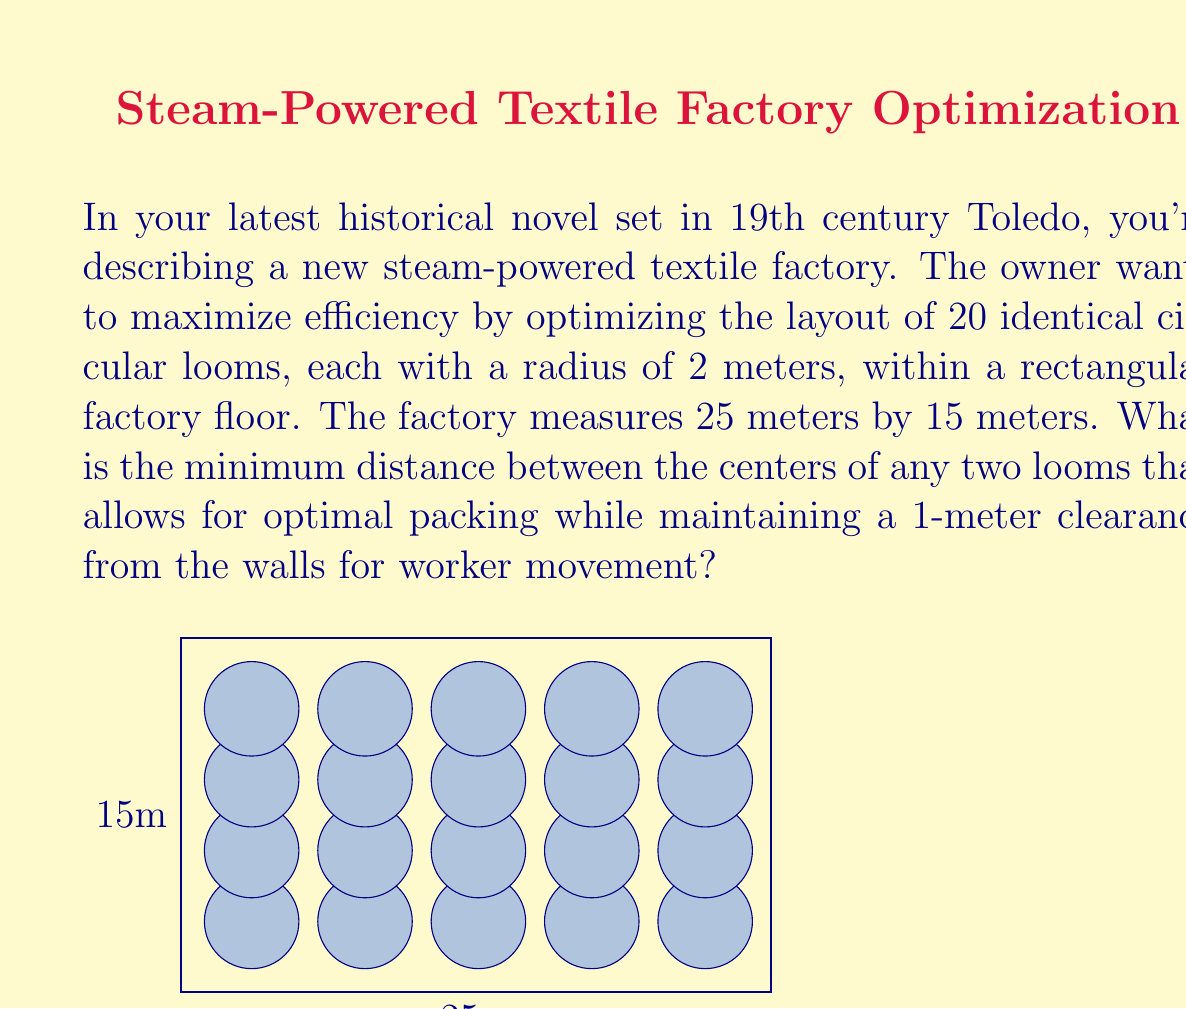Teach me how to tackle this problem. To solve this problem, we'll use computational geometry techniques:

1. First, we need to account for the 1-meter clearance from the walls. This reduces our effective area to 23m x 13m.

2. For optimal packing of circles, we use a hexagonal close packing arrangement. In this arrangement, the distance between circle centers is equal to their diameter.

3. Let $d$ be the distance between loom centers. Given the loom radius of 2m, we have:
   $d = 2r + x$, where $r = 2$ and $x$ is the extra space between looms.

4. In the longer dimension (23m), we can fit:
   $n_1 = \lfloor \frac{23}{d} \rfloor + 1$ looms

5. In the shorter dimension (13m), we can fit:
   $n_2 = \lfloor \frac{13}{\frac{\sqrt{3}}{2}d} \rfloor + 1$ looms

6. We need to maximize $n_1 \times n_2$ while ensuring it's at least 20 (the number of looms).

7. Through iterative calculation, we find that the optimal arrangement is 5 x 4 looms.

8. For 5 looms in 23m: $5d = 23$, so $d = \frac{23}{5} = 4.6$m

9. We can verify this works for the shorter dimension:
   $13 > \frac{\sqrt{3}}{2} \times 4.6 \times 3 + 4.6 = 12.98$m

10. Finally, we calculate $x$:
    $4.6 = 2 \times 2 + x$
    $x = 0.6$m

Therefore, the minimum distance between loom centers is 4.6m, which allows for a 0.6m gap between the edges of the looms.
Answer: 4.6 meters 